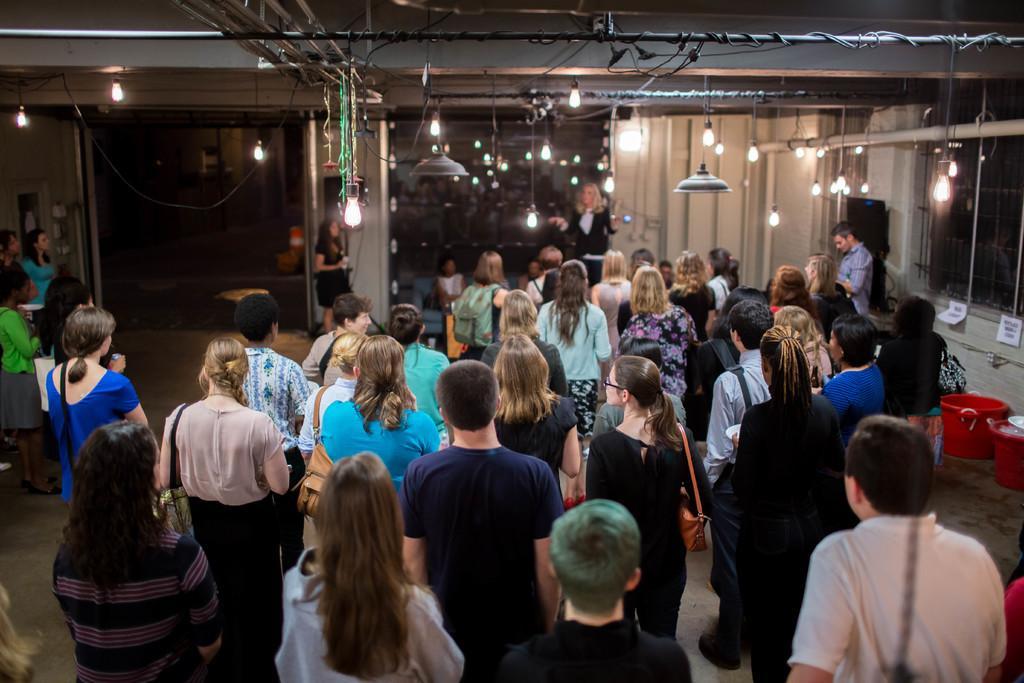Describe this image in one or two sentences. In this image we can see men and women are standing. Background of the image, one lady is standing. She is wearing black color coat and we can see white color wall with windows and pipes. At the top of the image, roof is there and lights are handed down from the roof. 